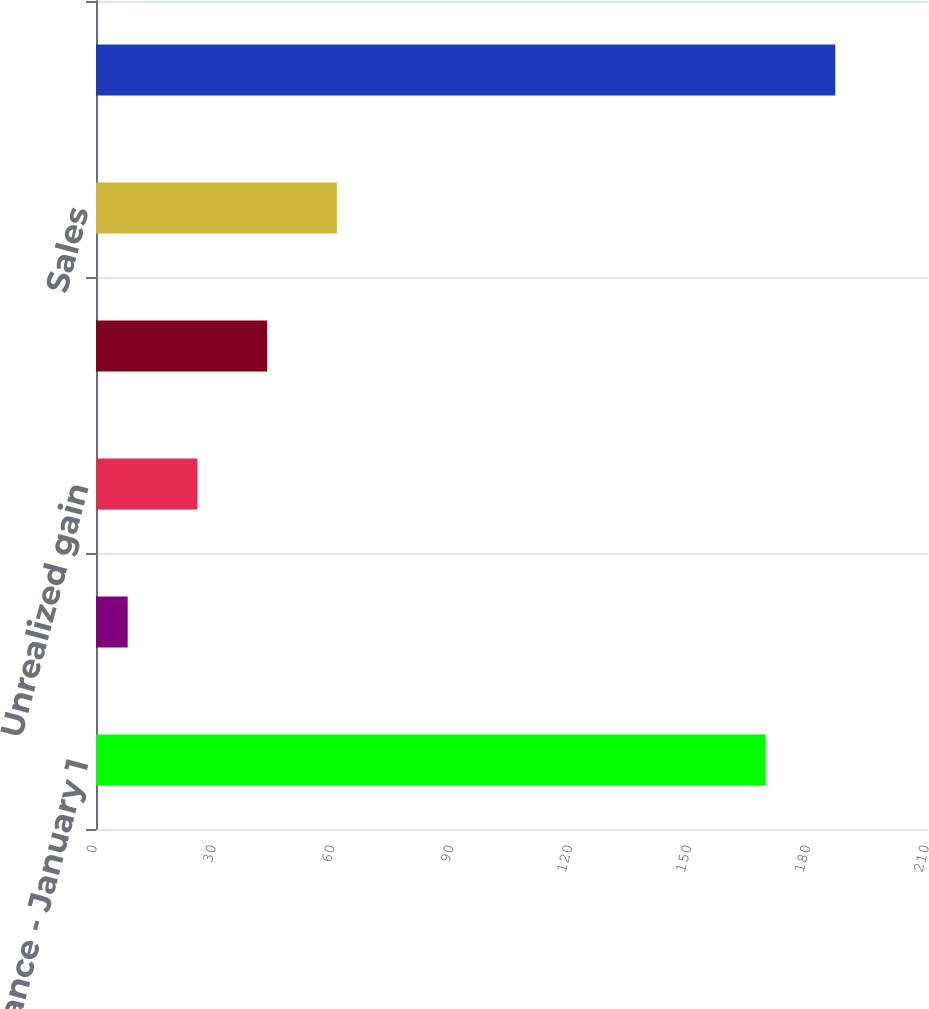Convert chart to OTSL. <chart><loc_0><loc_0><loc_500><loc_500><bar_chart><fcel>Beginning balance - January 1<fcel>Realized gain/(loss)<fcel>Unrealized gain<fcel>Purchases<fcel>Sales<fcel>Ending balance - December 31<nl><fcel>169<fcel>8<fcel>25.6<fcel>43.2<fcel>60.8<fcel>186.6<nl></chart> 